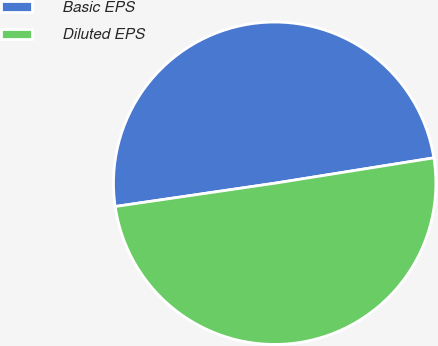Convert chart to OTSL. <chart><loc_0><loc_0><loc_500><loc_500><pie_chart><fcel>Basic EPS<fcel>Diluted EPS<nl><fcel>49.79%<fcel>50.21%<nl></chart> 